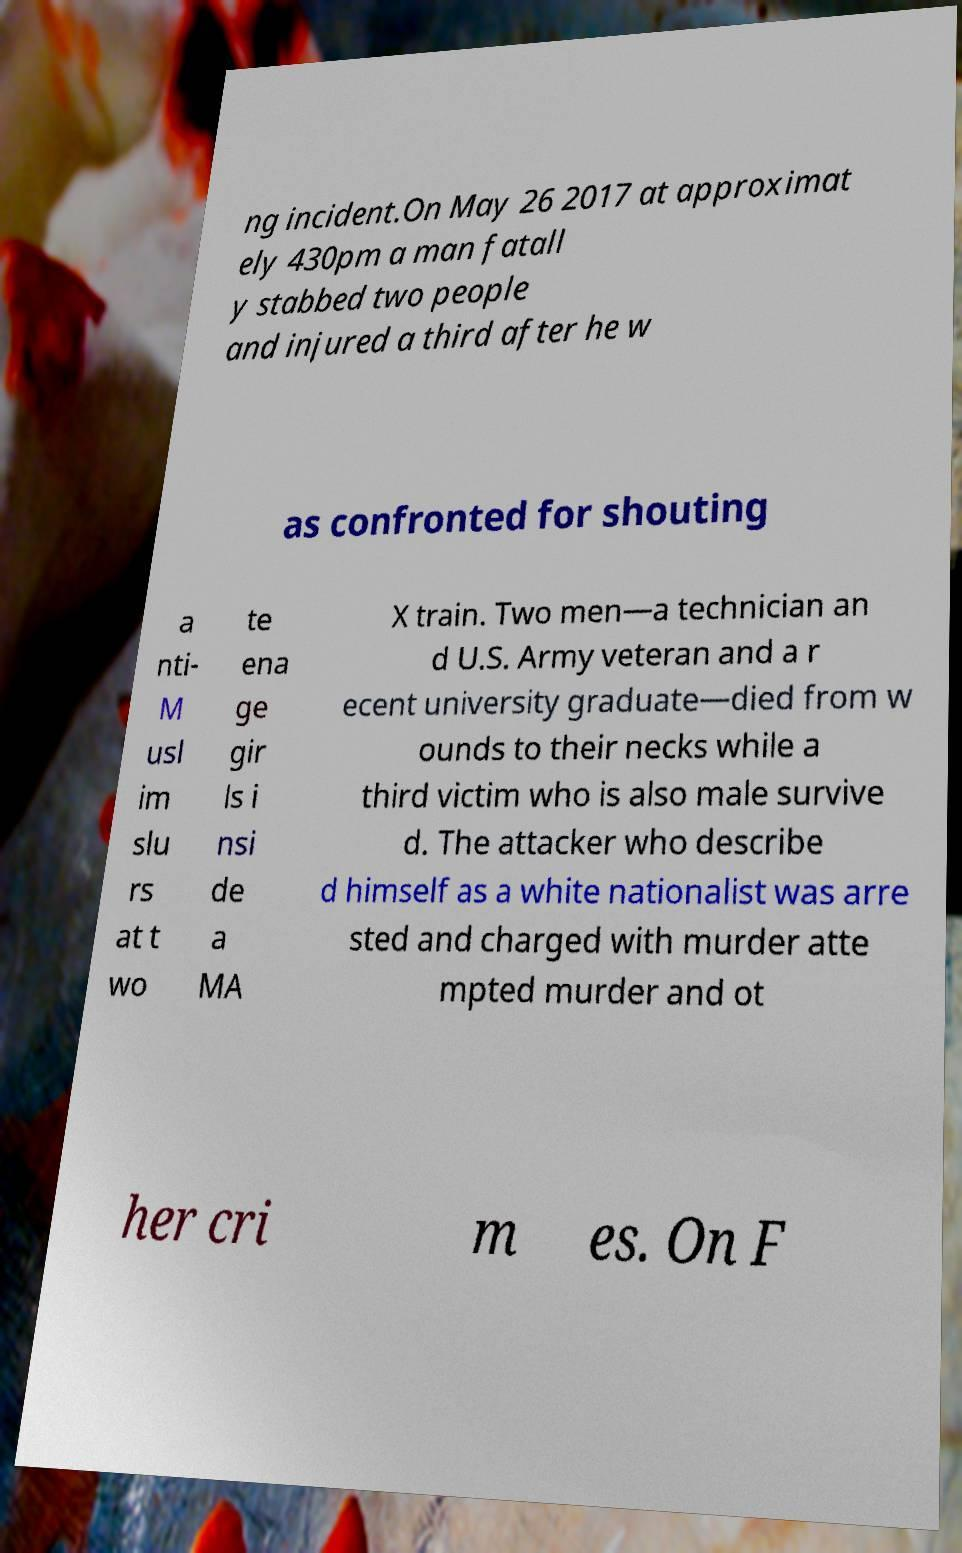I need the written content from this picture converted into text. Can you do that? ng incident.On May 26 2017 at approximat ely 430pm a man fatall y stabbed two people and injured a third after he w as confronted for shouting a nti- M usl im slu rs at t wo te ena ge gir ls i nsi de a MA X train. Two men—a technician an d U.S. Army veteran and a r ecent university graduate—died from w ounds to their necks while a third victim who is also male survive d. The attacker who describe d himself as a white nationalist was arre sted and charged with murder atte mpted murder and ot her cri m es. On F 